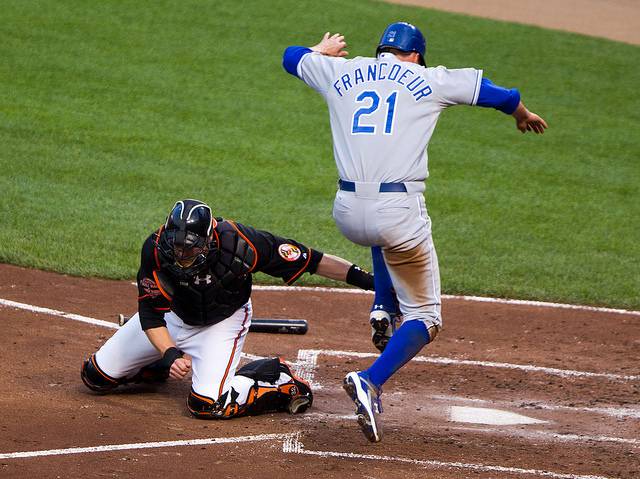<image>What is the name of the player wearing number 25? I don't know the name of the player wearing number 25. It could be Francoeur. What is the name of the player wearing number 25? It is unclear what is the name of the player wearing number 25. It could be 'francoeur' or 'jerry', but it is not possible to determine for sure. 